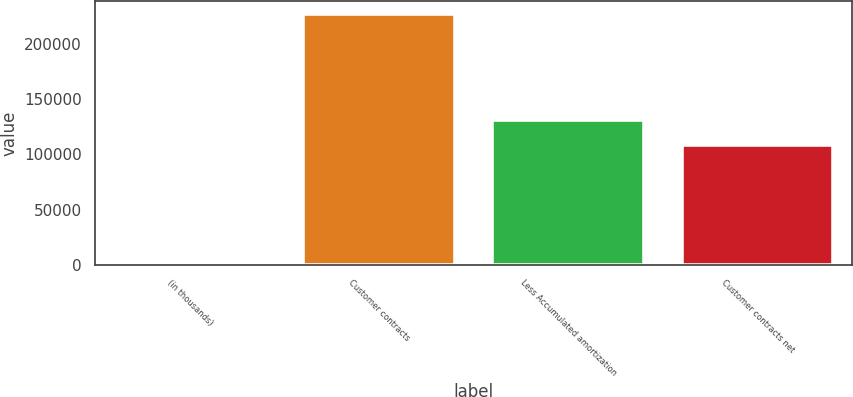<chart> <loc_0><loc_0><loc_500><loc_500><bar_chart><fcel>(in thousands)<fcel>Customer contracts<fcel>Less Accumulated amortization<fcel>Customer contracts net<nl><fcel>2011<fcel>227281<fcel>130875<fcel>108348<nl></chart> 